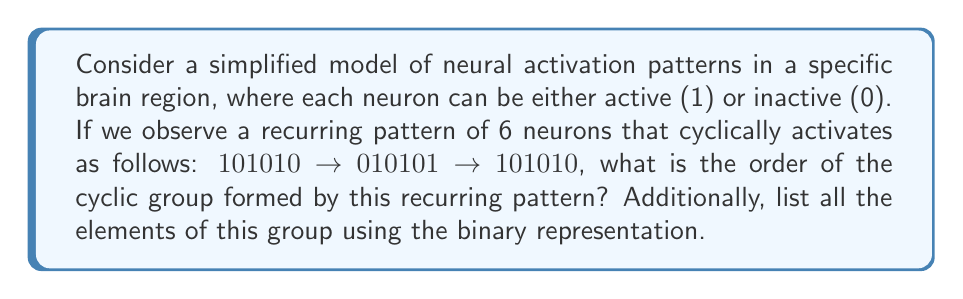What is the answer to this math problem? To solve this problem, we need to understand the concept of cyclic groups and how it applies to the given neural activation pattern:

1) First, let's identify the elements of the group:
   - State 1: 101010
   - State 2: 010101

2) We observe that after two shifts, the pattern returns to its original state. This means that the group has 2 elements.

3) In group theory, we denote the identity element as $e$ and the generator of the group as $a$. In this case:
   - $e$ = 101010 (the initial state)
   - $a$ = 010101 (the state after one shift)

4) The group operation here is the cyclic shift of the pattern. Let's see how it works:
   - $e \cdot e = e$ (shifting 101010 by 0 positions)
   - $e \cdot a = a$ (shifting 101010 by 1 position)
   - $a \cdot a = e$ (shifting 010101 by 1 position, which returns to 101010)

5) This forms a cyclic group of order 2, which is isomorphic to the group $\mathbb{Z}_2$ (the integers modulo 2).

6) In general, for a cyclic group $\langle a \rangle$, the order of the group is the smallest positive integer $n$ such that $a^n = e$. Here, $a^2 = e$, so the order is 2.

7) The elements of this group in binary representation are:
   $\{101010, 010101\}$

This simplified model demonstrates how recurring neural activation patterns can be represented as elements of a cyclic group, providing a mathematical framework for analyzing brain activity patterns.
Answer: The order of the cyclic group is 2. The elements of the group in binary representation are $\{101010, 010101\}$. 